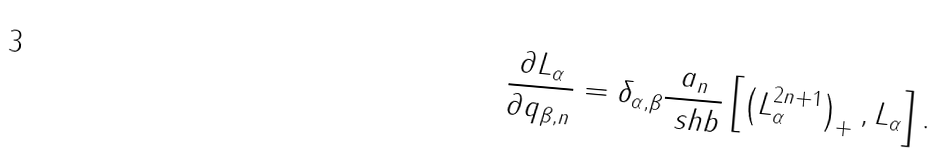<formula> <loc_0><loc_0><loc_500><loc_500>\frac { \partial L _ { \alpha } } { \partial q _ { \beta , n } } = \delta _ { \alpha , \beta } \frac { a _ { n } } { \ s h b } \left [ \left ( L _ { \alpha } ^ { 2 n + 1 } \right ) _ { + } , L _ { \alpha } \right ] .</formula> 